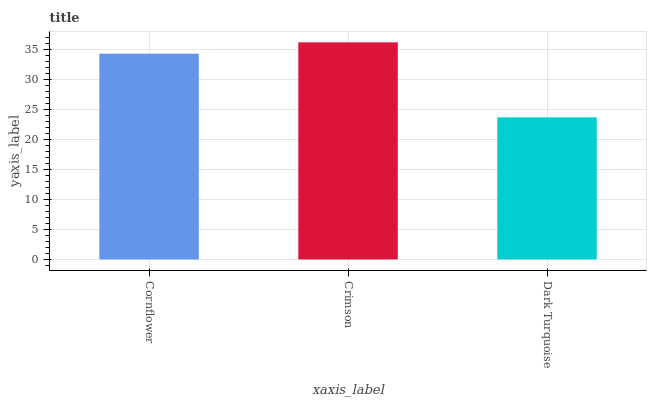Is Crimson the minimum?
Answer yes or no. No. Is Dark Turquoise the maximum?
Answer yes or no. No. Is Crimson greater than Dark Turquoise?
Answer yes or no. Yes. Is Dark Turquoise less than Crimson?
Answer yes or no. Yes. Is Dark Turquoise greater than Crimson?
Answer yes or no. No. Is Crimson less than Dark Turquoise?
Answer yes or no. No. Is Cornflower the high median?
Answer yes or no. Yes. Is Cornflower the low median?
Answer yes or no. Yes. Is Dark Turquoise the high median?
Answer yes or no. No. Is Crimson the low median?
Answer yes or no. No. 